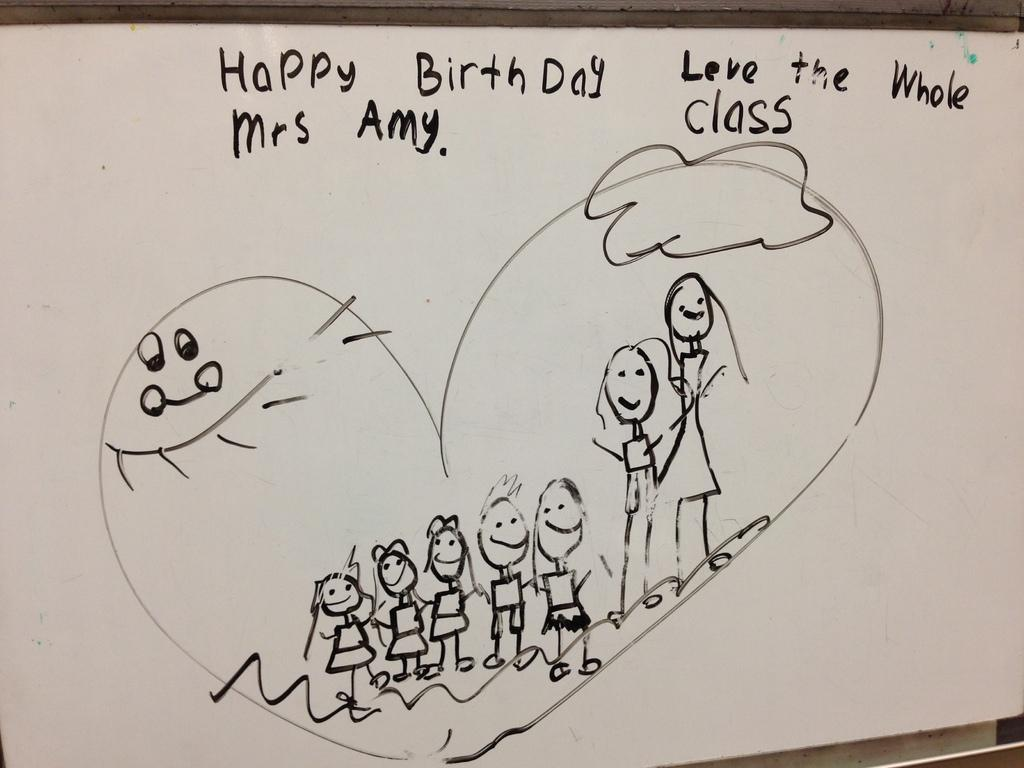What is the main object in the center of the image? There is a board in the center of the image. What is depicted on the board? There is a drawing on the board. What else can be seen on the board besides the drawing? There is text written on the board. What type of texture can be seen on the field in the image? There is no field present in the image; it features a board with a drawing and text. 